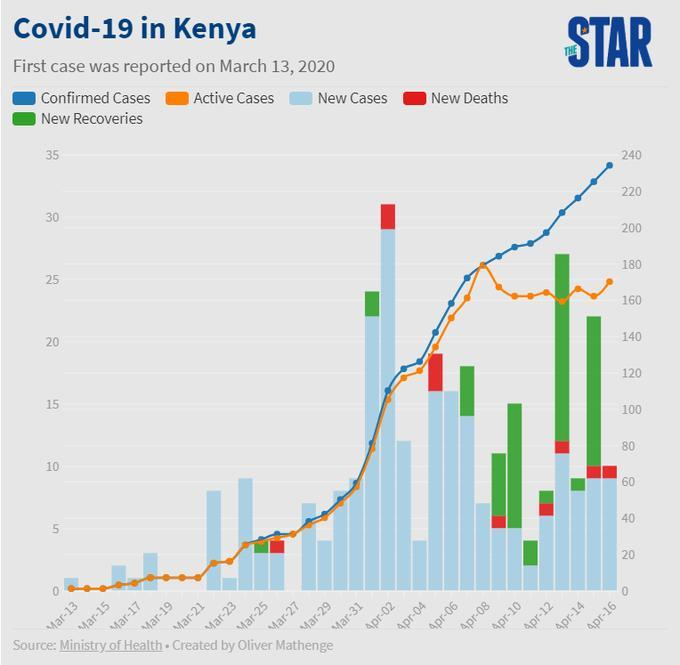What is the total number of new cases and new deaths on April 16, taken together?
Answer the question with a short phrase. 70 What is the number of new deaths on April 15? 10 What is the number of new recoveries on April 15? 80 What is the number of new deaths on April 16? 10 